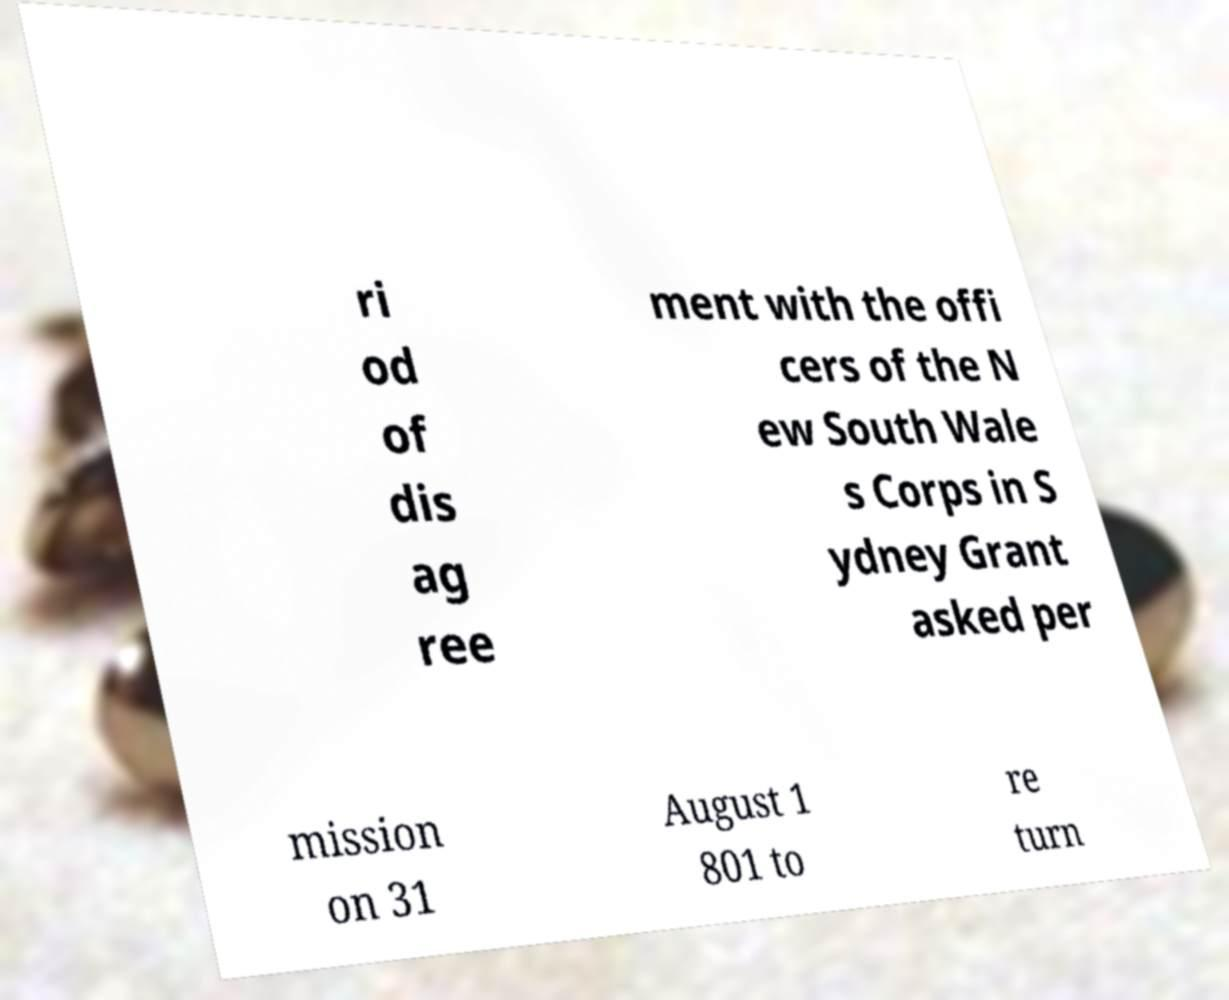Can you accurately transcribe the text from the provided image for me? ri od of dis ag ree ment with the offi cers of the N ew South Wale s Corps in S ydney Grant asked per mission on 31 August 1 801 to re turn 